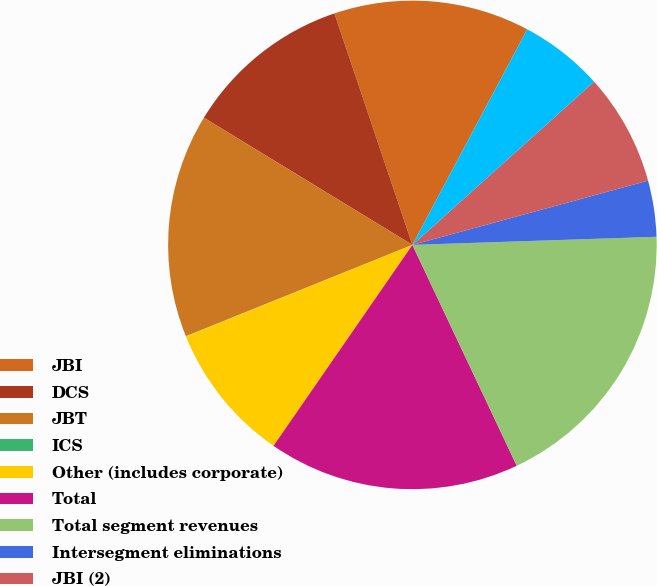<chart> <loc_0><loc_0><loc_500><loc_500><pie_chart><fcel>JBI<fcel>DCS<fcel>JBT<fcel>ICS<fcel>Other (includes corporate)<fcel>Total<fcel>Total segment revenues<fcel>Intersegment eliminations<fcel>JBI (2)<fcel>JBT(3)<nl><fcel>12.96%<fcel>11.11%<fcel>14.81%<fcel>0.02%<fcel>9.26%<fcel>16.65%<fcel>18.5%<fcel>3.71%<fcel>7.41%<fcel>5.56%<nl></chart> 